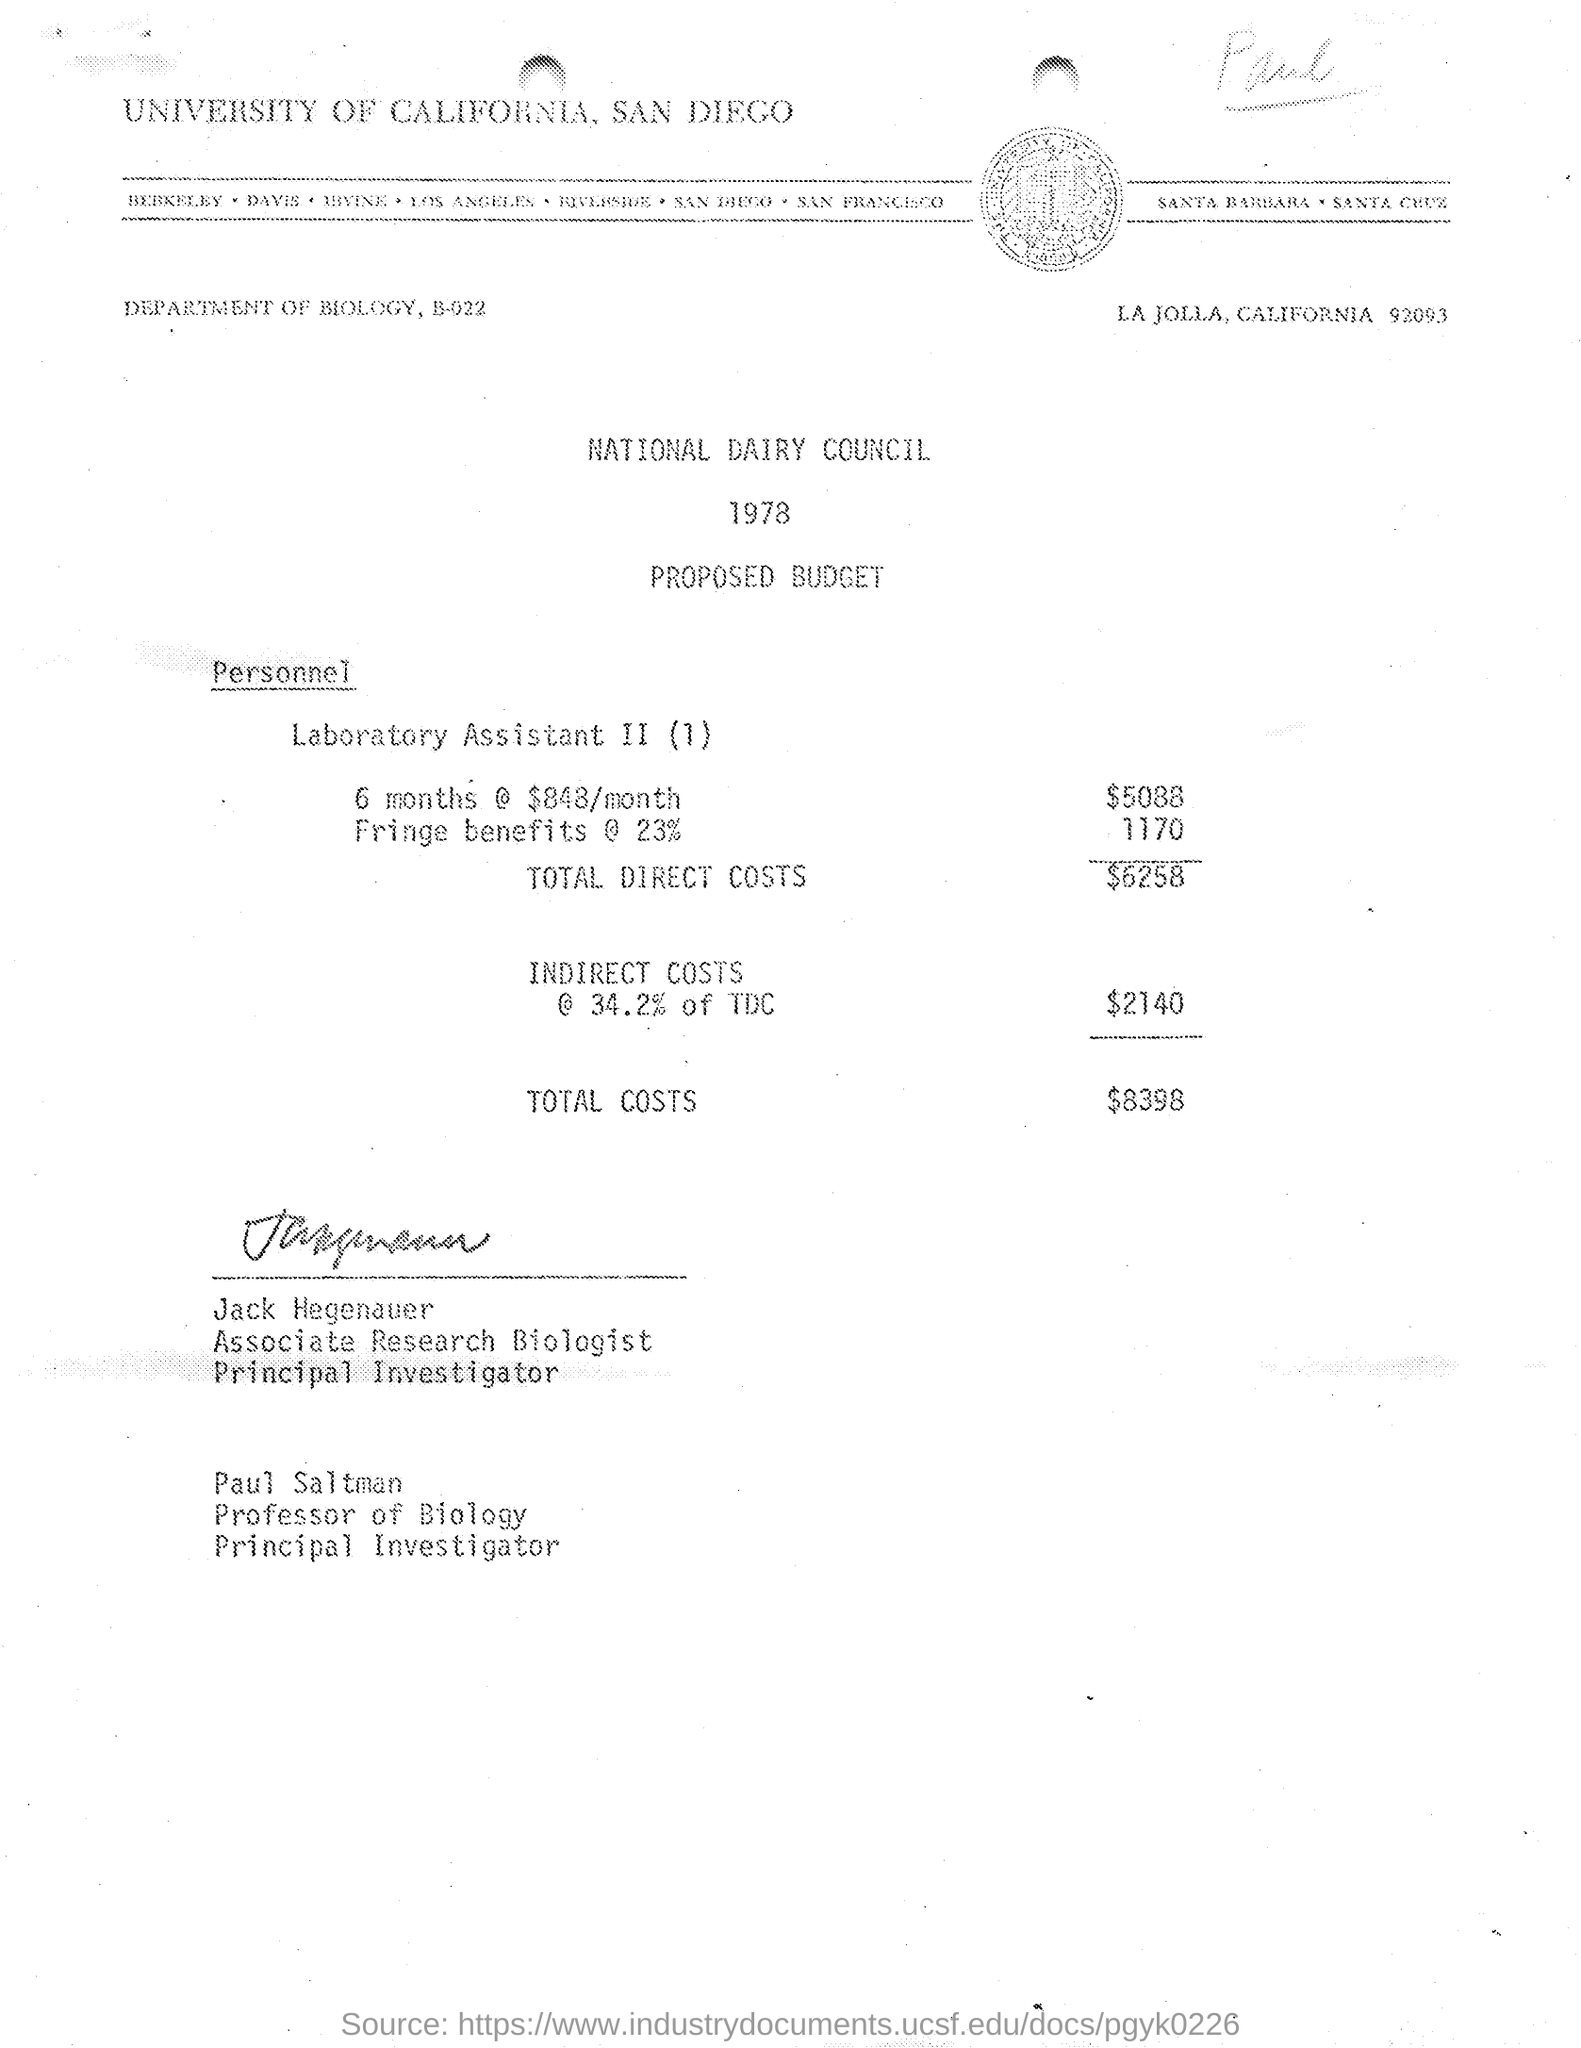Can you give me a breakdown of the total costs presented in the budget? The total costs in the budget include the direct costs of the Laboratory Assistant II position, which is $5,088 for 6 months, fringe benefits at 23% amounting to $1,170, and indirect costs calculated at 34.2% of the total direct costs, which is $2,140. This results in total costs of $8,398. 